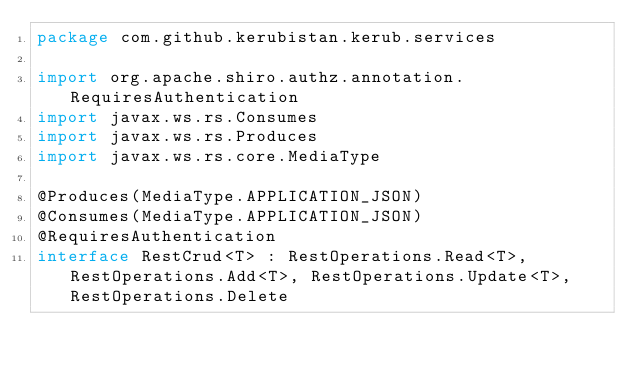Convert code to text. <code><loc_0><loc_0><loc_500><loc_500><_Kotlin_>package com.github.kerubistan.kerub.services

import org.apache.shiro.authz.annotation.RequiresAuthentication
import javax.ws.rs.Consumes
import javax.ws.rs.Produces
import javax.ws.rs.core.MediaType

@Produces(MediaType.APPLICATION_JSON)
@Consumes(MediaType.APPLICATION_JSON)
@RequiresAuthentication
interface RestCrud<T> : RestOperations.Read<T>, RestOperations.Add<T>, RestOperations.Update<T>, RestOperations.Delete
</code> 